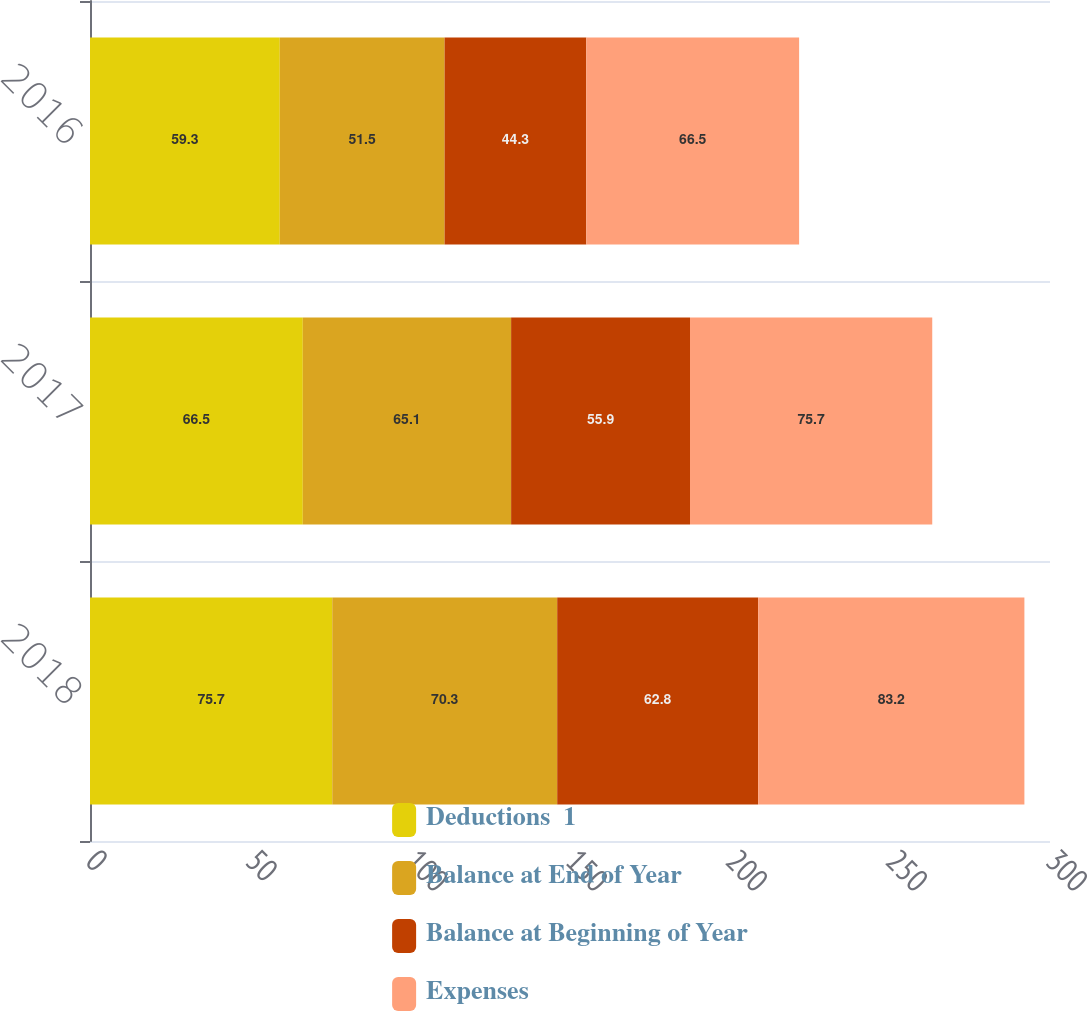<chart> <loc_0><loc_0><loc_500><loc_500><stacked_bar_chart><ecel><fcel>2018<fcel>2017<fcel>2016<nl><fcel>Deductions  1<fcel>75.7<fcel>66.5<fcel>59.3<nl><fcel>Balance at End of Year<fcel>70.3<fcel>65.1<fcel>51.5<nl><fcel>Balance at Beginning of Year<fcel>62.8<fcel>55.9<fcel>44.3<nl><fcel>Expenses<fcel>83.2<fcel>75.7<fcel>66.5<nl></chart> 